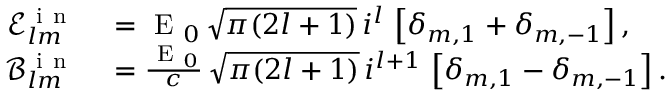Convert formula to latex. <formula><loc_0><loc_0><loc_500><loc_500>\begin{array} { r l } { \mathcal { E } _ { l m } ^ { i n } } & = E _ { 0 } \, \sqrt { \pi ( 2 l + 1 ) } \, i ^ { l } \, \left [ \delta _ { m , 1 } + \delta _ { m , - 1 } \right ] , } \\ { \mathcal { B } _ { l m } ^ { i n } } & = \frac { E _ { 0 } } { c } \, \sqrt { \pi ( 2 l + 1 ) } \, i ^ { l + 1 } \, \left [ \delta _ { m , 1 } - \delta _ { m , - 1 } \right ] . } \end{array}</formula> 